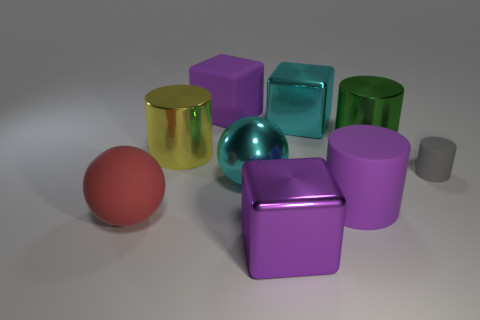What number of matte things are either blue spheres or purple cylinders? In the image, you will find one matte object that falls into the categories of either a blue sphere or a purple cylinder. Specifically, it is the purple cylinder located centrally among the collection of variously colored and shaped objects. 